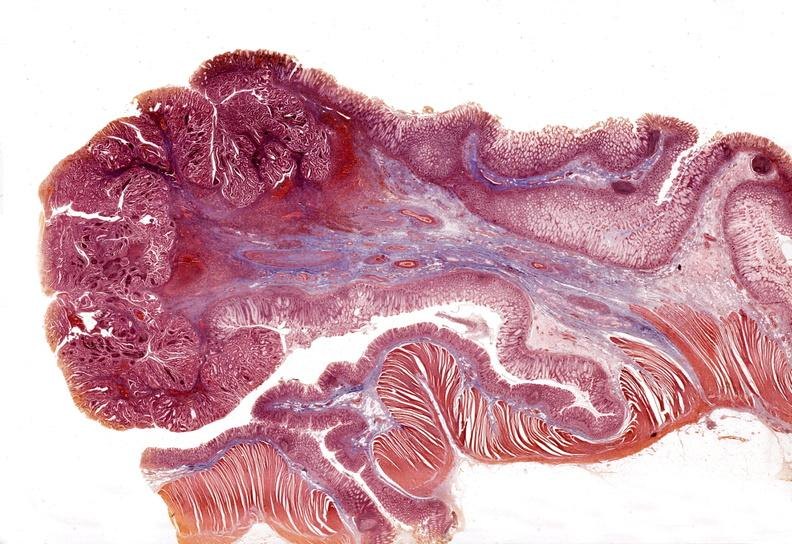what is present?
Answer the question using a single word or phrase. Gastrointestinal 